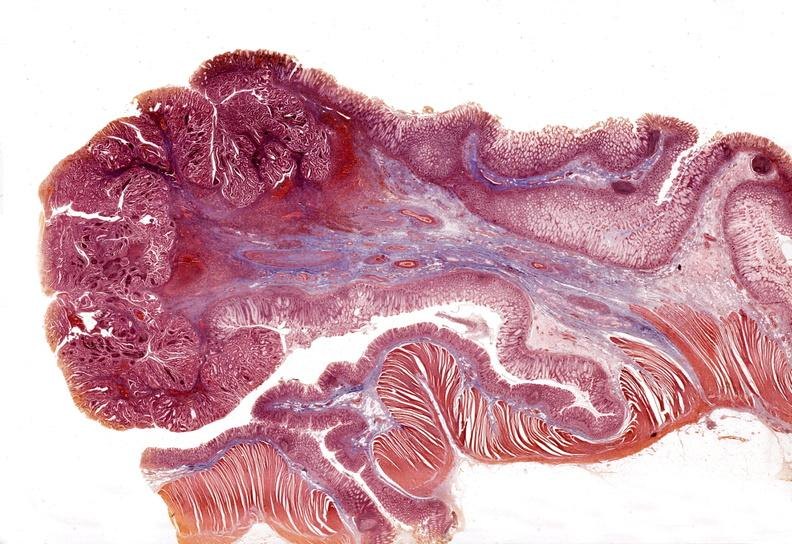what is present?
Answer the question using a single word or phrase. Gastrointestinal 